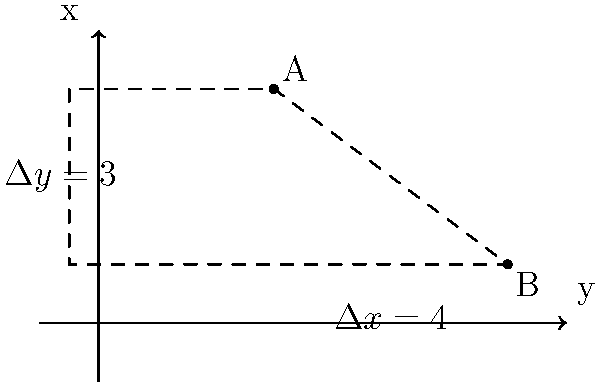Two historical sites, A and B, are located in the river area of a city. On the city map with a coordinate system, site A is at (3, 4) and site B is at (7, 1). Calculate the straight-line distance between these two heritage sites. To find the distance between two points on a coordinate plane, we can use the distance formula, which is derived from the Pythagorean theorem. Let's follow these steps:

1) The distance formula is:
   $$d = \sqrt{(x_2 - x_1)^2 + (y_2 - y_1)^2}$$
   where $(x_1, y_1)$ are the coordinates of the first point and $(x_2, y_2)$ are the coordinates of the second point.

2) In this case:
   Point A: $(x_1, y_1) = (3, 4)$
   Point B: $(x_2, y_2) = (7, 1)$

3) Let's substitute these values into the formula:
   $$d = \sqrt{(7 - 3)^2 + (1 - 4)^2}$$

4) Simplify inside the parentheses:
   $$d = \sqrt{4^2 + (-3)^2}$$

5) Calculate the squares:
   $$d = \sqrt{16 + 9}$$

6) Add inside the square root:
   $$d = \sqrt{25}$$

7) Simplify:
   $$d = 5$$

Therefore, the straight-line distance between the two heritage sites is 5 units on the city map scale.
Answer: 5 units 